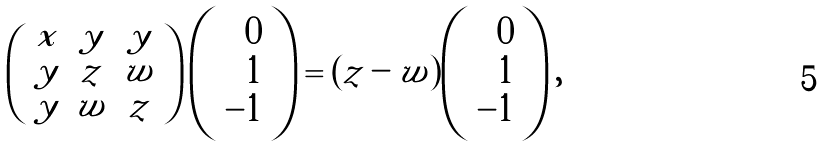<formula> <loc_0><loc_0><loc_500><loc_500>\left ( \begin{array} { c c c } x & y & y \\ y & z & w \\ y & w & z \end{array} \right ) \left ( \begin{array} { r } 0 \\ 1 \\ - 1 \end{array} \right ) = ( z - w ) \left ( \begin{array} { r } 0 \\ 1 \\ - 1 \end{array} \right ) ,</formula> 